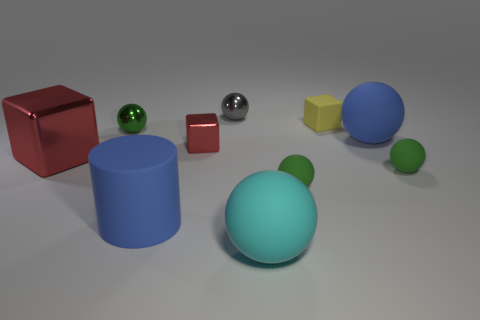How many green balls must be subtracted to get 1 green balls? 2 Subtract all blue balls. How many balls are left? 5 Subtract all yellow blocks. How many blocks are left? 2 Subtract 2 blocks. How many blocks are left? 1 Subtract all balls. How many objects are left? 4 Subtract all blue blocks. How many green spheres are left? 3 Add 3 small gray spheres. How many small gray spheres are left? 4 Add 8 small gray objects. How many small gray objects exist? 9 Subtract 1 green balls. How many objects are left? 9 Subtract all yellow blocks. Subtract all purple cylinders. How many blocks are left? 2 